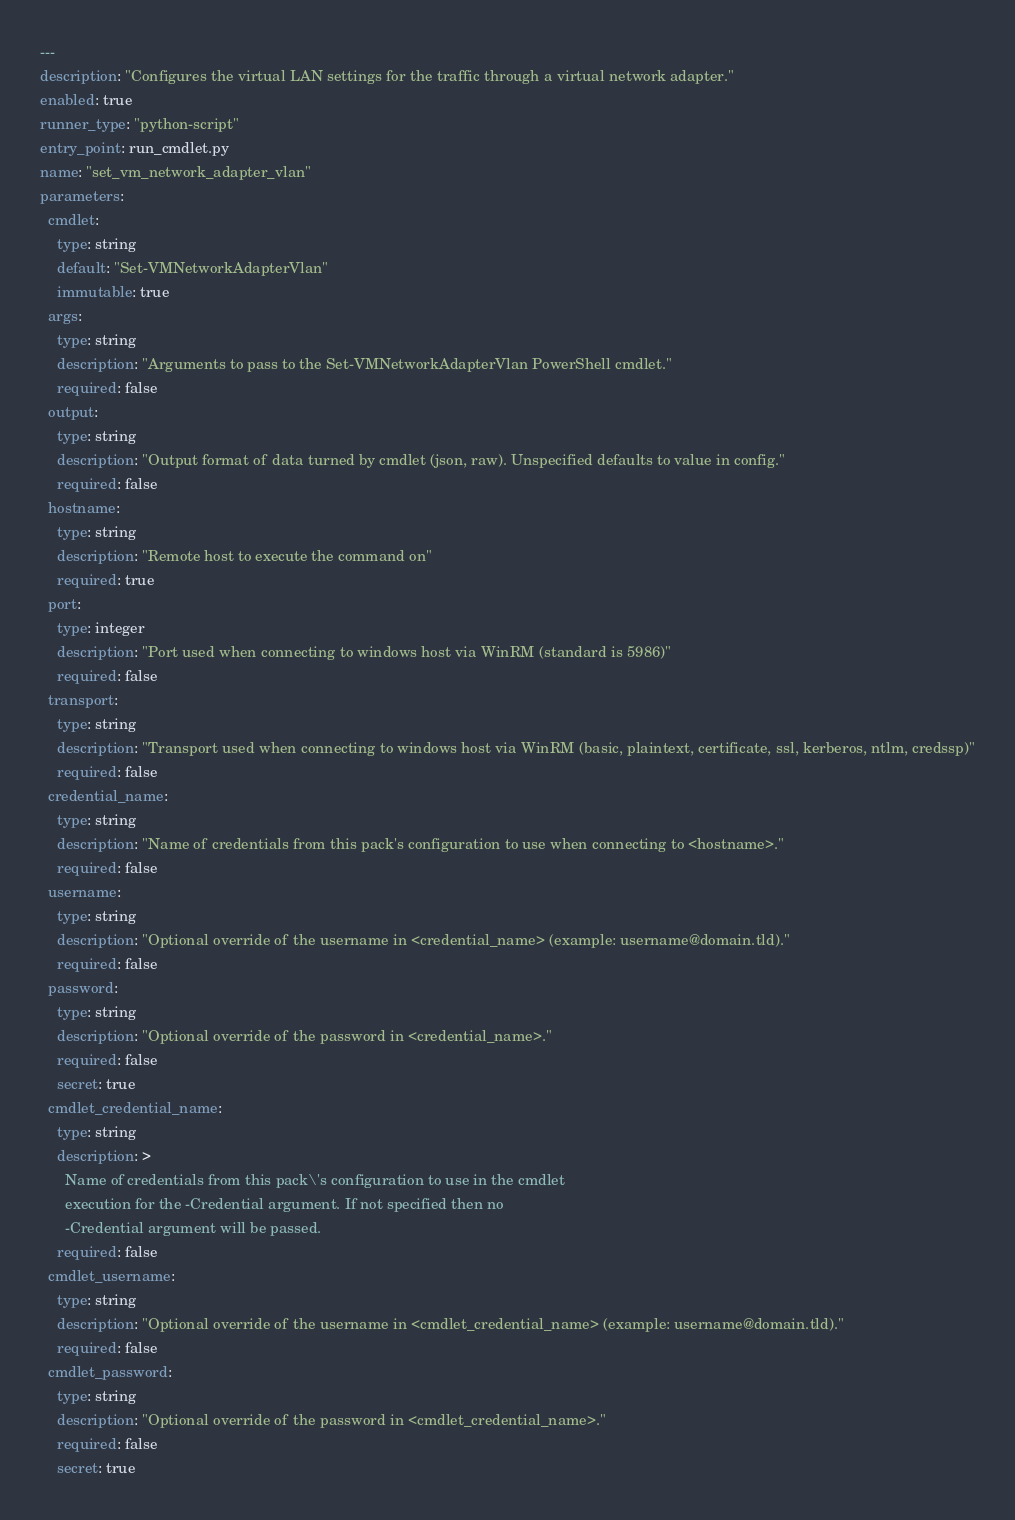Convert code to text. <code><loc_0><loc_0><loc_500><loc_500><_YAML_>---
description: "Configures the virtual LAN settings for the traffic through a virtual network adapter."
enabled: true
runner_type: "python-script"
entry_point: run_cmdlet.py
name: "set_vm_network_adapter_vlan"
parameters:
  cmdlet:
    type: string
    default: "Set-VMNetworkAdapterVlan"
    immutable: true
  args:
    type: string
    description: "Arguments to pass to the Set-VMNetworkAdapterVlan PowerShell cmdlet."
    required: false
  output:
    type: string
    description: "Output format of data turned by cmdlet (json, raw). Unspecified defaults to value in config."
    required: false
  hostname:
    type: string
    description: "Remote host to execute the command on"
    required: true
  port:
    type: integer
    description: "Port used when connecting to windows host via WinRM (standard is 5986)"
    required: false
  transport:
    type: string
    description: "Transport used when connecting to windows host via WinRM (basic, plaintext, certificate, ssl, kerberos, ntlm, credssp)"
    required: false
  credential_name:
    type: string
    description: "Name of credentials from this pack's configuration to use when connecting to <hostname>."
    required: false
  username:
    type: string
    description: "Optional override of the username in <credential_name> (example: username@domain.tld)."
    required: false
  password:
    type: string
    description: "Optional override of the password in <credential_name>."
    required: false
    secret: true
  cmdlet_credential_name:
    type: string
    description: >
      Name of credentials from this pack\'s configuration to use in the cmdlet
      execution for the -Credential argument. If not specified then no
      -Credential argument will be passed.
    required: false
  cmdlet_username:
    type: string
    description: "Optional override of the username in <cmdlet_credential_name> (example: username@domain.tld)."
    required: false
  cmdlet_password:
    type: string
    description: "Optional override of the password in <cmdlet_credential_name>."
    required: false
    secret: true
</code> 